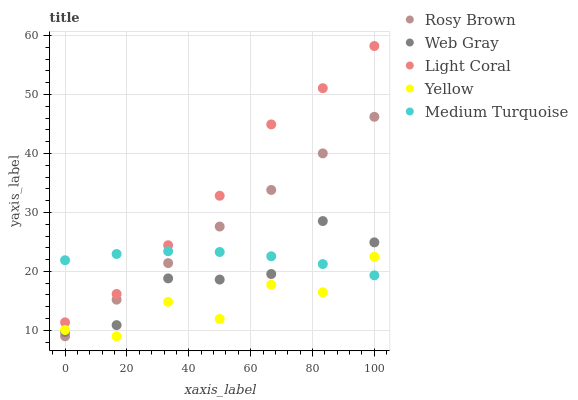Does Yellow have the minimum area under the curve?
Answer yes or no. Yes. Does Light Coral have the maximum area under the curve?
Answer yes or no. Yes. Does Rosy Brown have the minimum area under the curve?
Answer yes or no. No. Does Rosy Brown have the maximum area under the curve?
Answer yes or no. No. Is Rosy Brown the smoothest?
Answer yes or no. Yes. Is Yellow the roughest?
Answer yes or no. Yes. Is Web Gray the smoothest?
Answer yes or no. No. Is Web Gray the roughest?
Answer yes or no. No. Does Rosy Brown have the lowest value?
Answer yes or no. Yes. Does Web Gray have the lowest value?
Answer yes or no. No. Does Light Coral have the highest value?
Answer yes or no. Yes. Does Rosy Brown have the highest value?
Answer yes or no. No. Is Yellow less than Light Coral?
Answer yes or no. Yes. Is Light Coral greater than Yellow?
Answer yes or no. Yes. Does Light Coral intersect Medium Turquoise?
Answer yes or no. Yes. Is Light Coral less than Medium Turquoise?
Answer yes or no. No. Is Light Coral greater than Medium Turquoise?
Answer yes or no. No. Does Yellow intersect Light Coral?
Answer yes or no. No. 